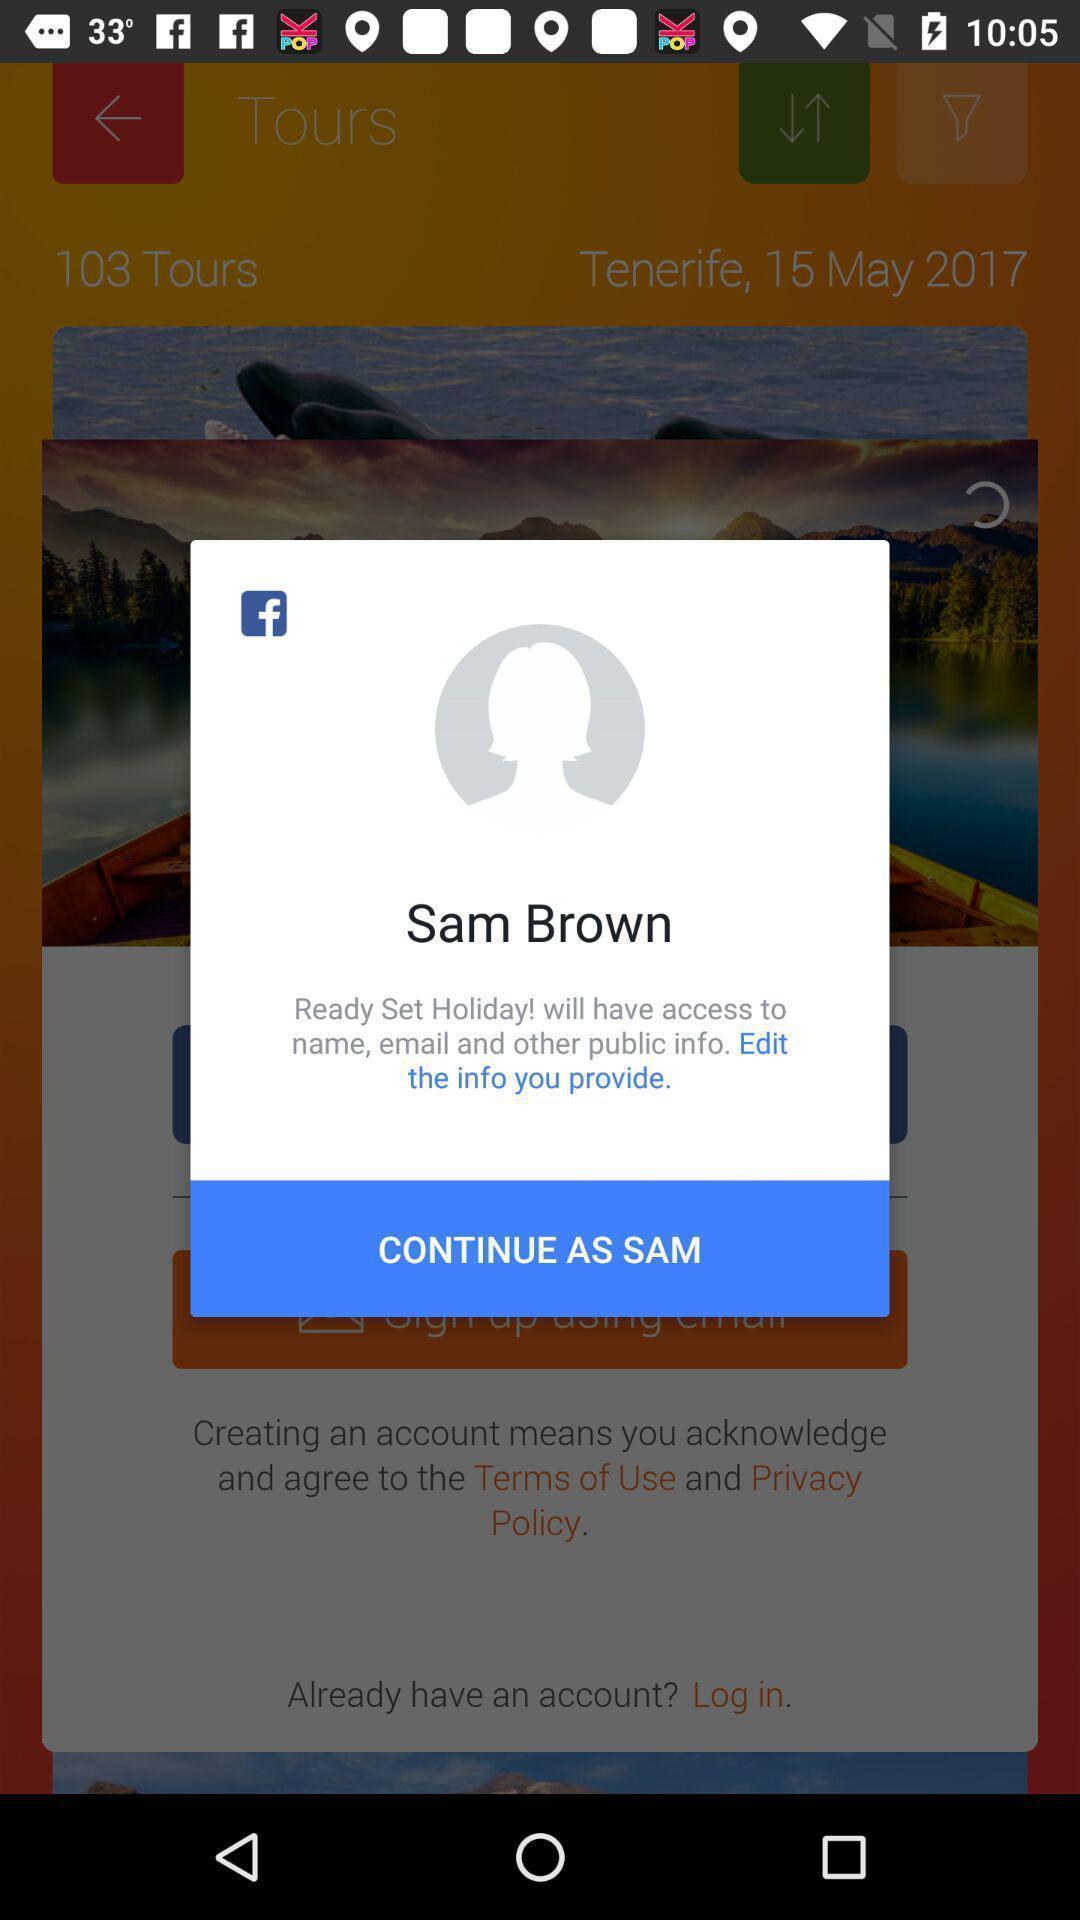Describe the content in this image. Pop-up asking permissions to access the user details. 